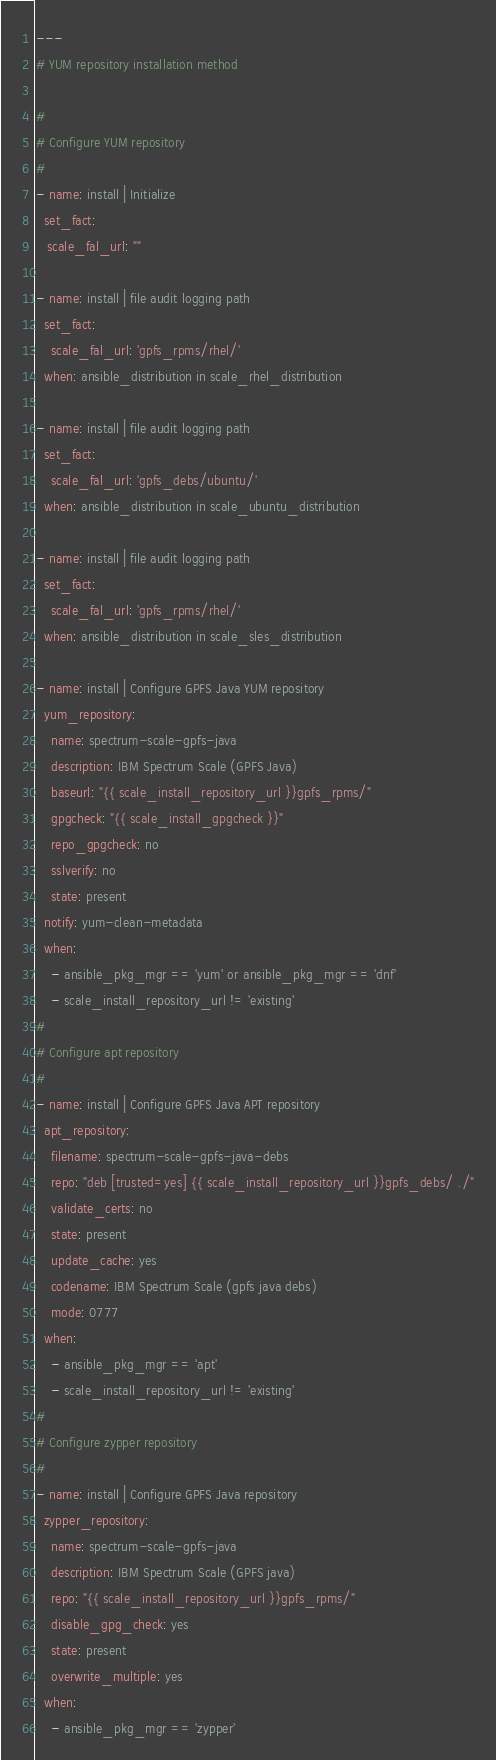<code> <loc_0><loc_0><loc_500><loc_500><_YAML_>---
# YUM repository installation method

#
# Configure YUM repository
#
- name: install | Initialize
  set_fact:
   scale_fal_url: ""

- name: install | file audit logging path
  set_fact:
    scale_fal_url: 'gpfs_rpms/rhel/'
  when: ansible_distribution in scale_rhel_distribution

- name: install | file audit logging path
  set_fact:
    scale_fal_url: 'gpfs_debs/ubuntu/'
  when: ansible_distribution in scale_ubuntu_distribution

- name: install | file audit logging path
  set_fact:
    scale_fal_url: 'gpfs_rpms/rhel/'
  when: ansible_distribution in scale_sles_distribution

- name: install | Configure GPFS Java YUM repository
  yum_repository:
    name: spectrum-scale-gpfs-java
    description: IBM Spectrum Scale (GPFS Java)
    baseurl: "{{ scale_install_repository_url }}gpfs_rpms/"
    gpgcheck: "{{ scale_install_gpgcheck }}"
    repo_gpgcheck: no
    sslverify: no
    state: present
  notify: yum-clean-metadata
  when:
    - ansible_pkg_mgr == 'yum' or ansible_pkg_mgr == 'dnf'
    - scale_install_repository_url != 'existing'
#
# Configure apt repository
#
- name: install | Configure GPFS Java APT repository
  apt_repository:
    filename: spectrum-scale-gpfs-java-debs
    repo: "deb [trusted=yes] {{ scale_install_repository_url }}gpfs_debs/ ./"
    validate_certs: no
    state: present
    update_cache: yes
    codename: IBM Spectrum Scale (gpfs java debs)
    mode: 0777
  when:
    - ansible_pkg_mgr == 'apt'
    - scale_install_repository_url != 'existing'
#
# Configure zypper repository
#
- name: install | Configure GPFS Java repository
  zypper_repository:
    name: spectrum-scale-gpfs-java
    description: IBM Spectrum Scale (GPFS java)
    repo: "{{ scale_install_repository_url }}gpfs_rpms/"
    disable_gpg_check: yes
    state: present
    overwrite_multiple: yes
  when:
    - ansible_pkg_mgr == 'zypper'</code> 